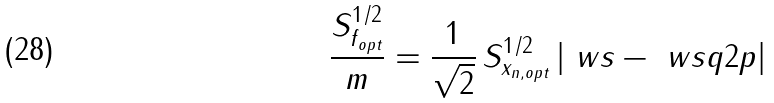<formula> <loc_0><loc_0><loc_500><loc_500>\frac { S ^ { 1 / 2 } _ { f _ { o p t } } } { m } = \frac { 1 } { \sqrt { 2 } } \, S ^ { 1 / 2 } _ { x _ { n , o p t } } \left | \ w s - \ w s q { 2 p } \right |</formula> 